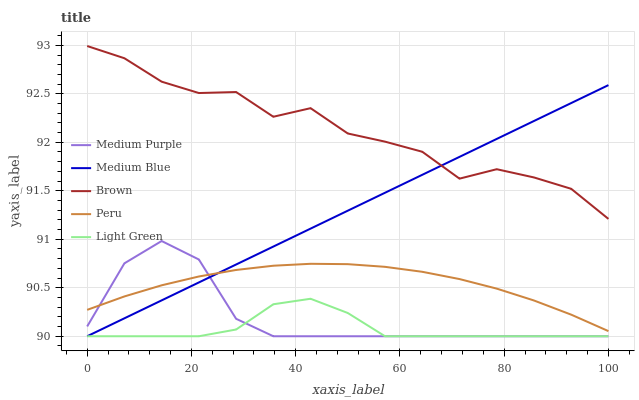Does Light Green have the minimum area under the curve?
Answer yes or no. Yes. Does Brown have the maximum area under the curve?
Answer yes or no. Yes. Does Medium Blue have the minimum area under the curve?
Answer yes or no. No. Does Medium Blue have the maximum area under the curve?
Answer yes or no. No. Is Medium Blue the smoothest?
Answer yes or no. Yes. Is Brown the roughest?
Answer yes or no. Yes. Is Brown the smoothest?
Answer yes or no. No. Is Medium Blue the roughest?
Answer yes or no. No. Does Medium Purple have the lowest value?
Answer yes or no. Yes. Does Brown have the lowest value?
Answer yes or no. No. Does Brown have the highest value?
Answer yes or no. Yes. Does Medium Blue have the highest value?
Answer yes or no. No. Is Light Green less than Peru?
Answer yes or no. Yes. Is Peru greater than Light Green?
Answer yes or no. Yes. Does Medium Purple intersect Light Green?
Answer yes or no. Yes. Is Medium Purple less than Light Green?
Answer yes or no. No. Is Medium Purple greater than Light Green?
Answer yes or no. No. Does Light Green intersect Peru?
Answer yes or no. No. 